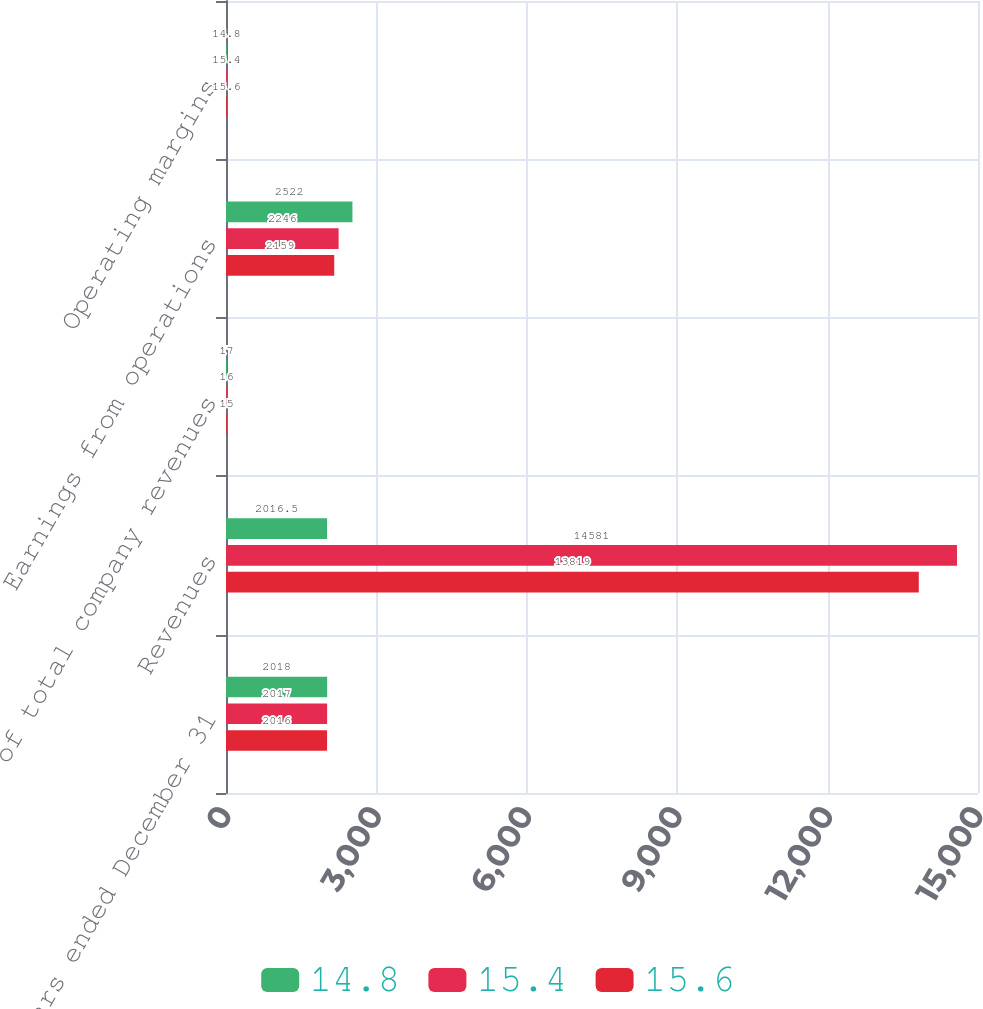<chart> <loc_0><loc_0><loc_500><loc_500><stacked_bar_chart><ecel><fcel>Years ended December 31<fcel>Revenues<fcel>of total company revenues<fcel>Earnings from operations<fcel>Operating margins<nl><fcel>14.8<fcel>2018<fcel>2016.5<fcel>17<fcel>2522<fcel>14.8<nl><fcel>15.4<fcel>2017<fcel>14581<fcel>16<fcel>2246<fcel>15.4<nl><fcel>15.6<fcel>2016<fcel>13819<fcel>15<fcel>2159<fcel>15.6<nl></chart> 